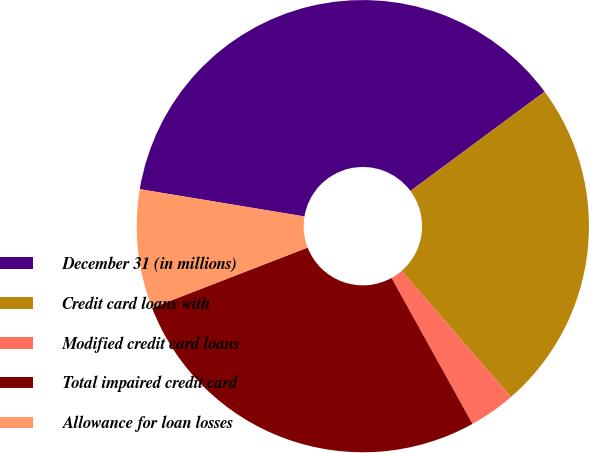Convert chart to OTSL. <chart><loc_0><loc_0><loc_500><loc_500><pie_chart><fcel>December 31 (in millions)<fcel>Credit card loans with<fcel>Modified credit card loans<fcel>Total impaired credit card<fcel>Allowance for loan losses<nl><fcel>37.25%<fcel>23.77%<fcel>3.31%<fcel>27.17%<fcel>8.5%<nl></chart> 